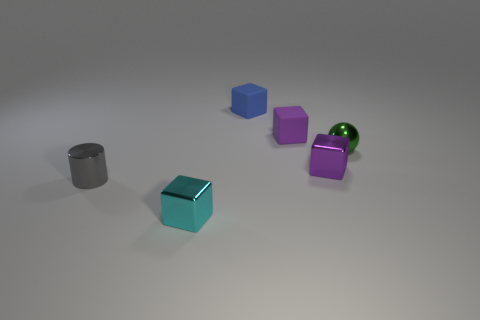Subtract all brown cubes. Subtract all blue cylinders. How many cubes are left? 4 Add 2 tiny green matte cylinders. How many objects exist? 8 Subtract all balls. How many objects are left? 5 Add 2 large purple rubber blocks. How many large purple rubber blocks exist? 2 Subtract 0 yellow cylinders. How many objects are left? 6 Subtract all red cylinders. Subtract all blue objects. How many objects are left? 5 Add 4 tiny metallic things. How many tiny metallic things are left? 8 